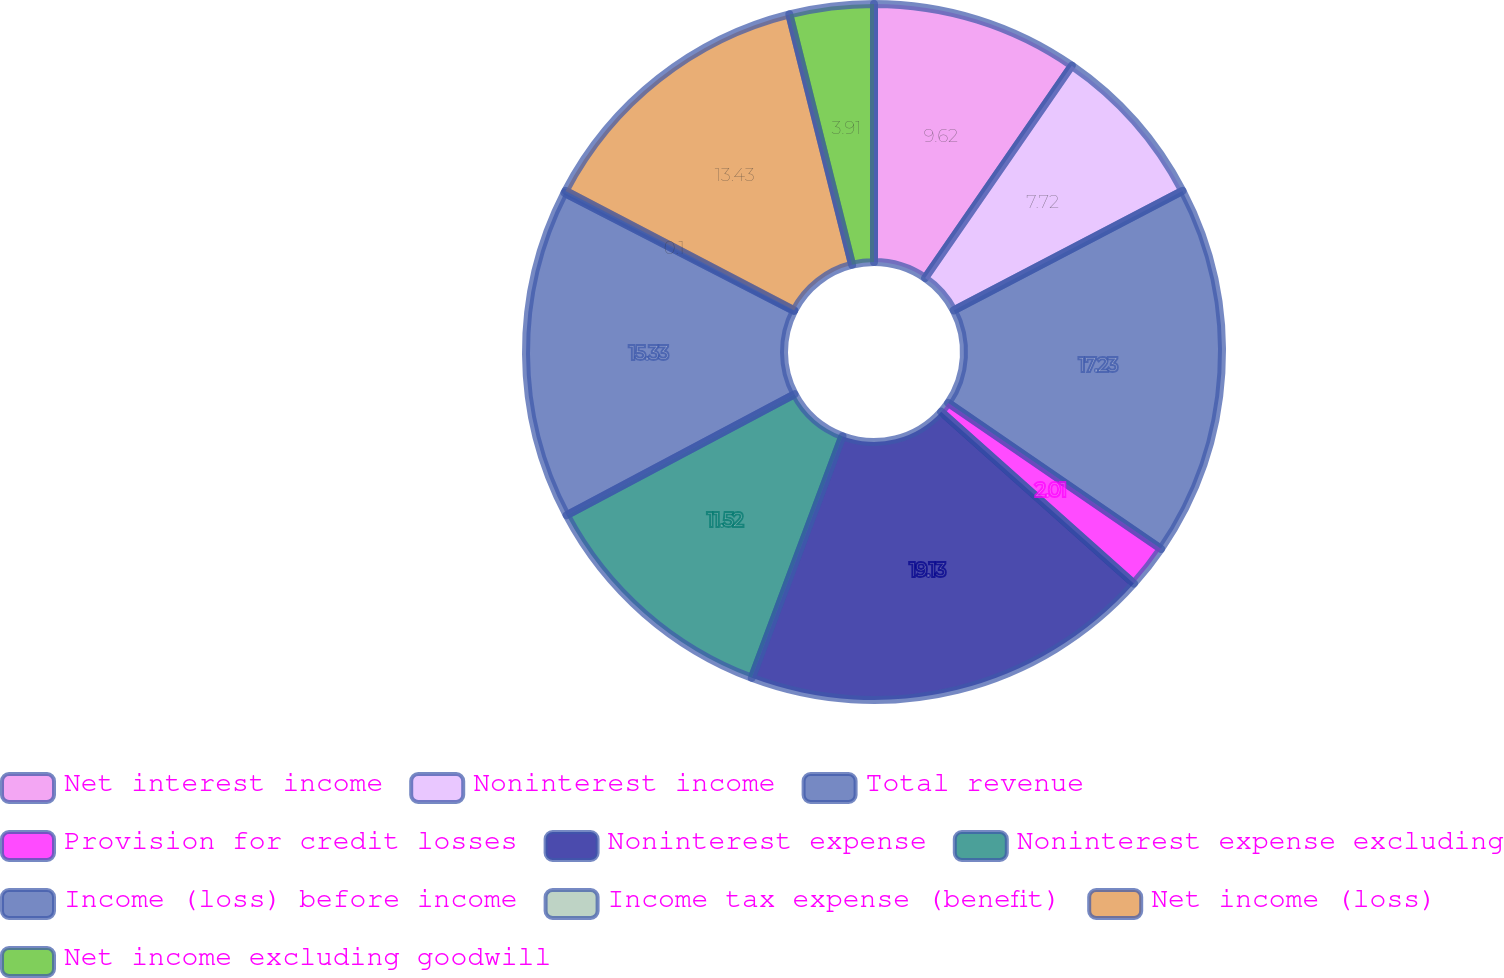Convert chart. <chart><loc_0><loc_0><loc_500><loc_500><pie_chart><fcel>Net interest income<fcel>Noninterest income<fcel>Total revenue<fcel>Provision for credit losses<fcel>Noninterest expense<fcel>Noninterest expense excluding<fcel>Income (loss) before income<fcel>Income tax expense (benefit)<fcel>Net income (loss)<fcel>Net income excluding goodwill<nl><fcel>9.62%<fcel>7.72%<fcel>17.23%<fcel>2.01%<fcel>19.13%<fcel>11.52%<fcel>15.33%<fcel>0.1%<fcel>13.43%<fcel>3.91%<nl></chart> 